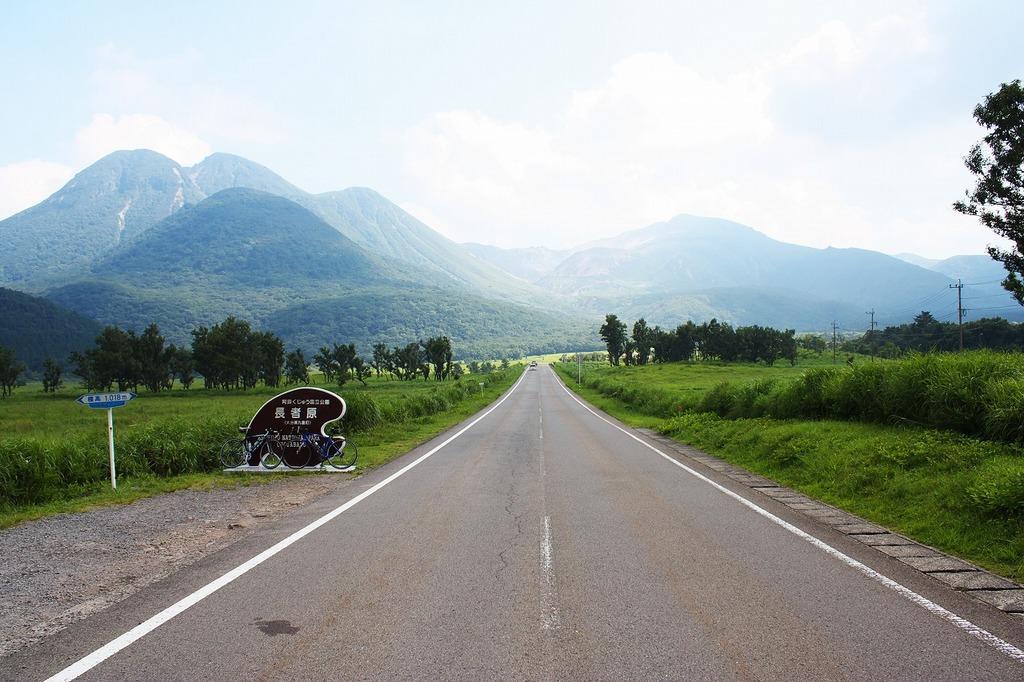How would you summarize this image in a sentence or two? The picture is taken along the countryside. In the foreground of the picture there are bicycles, soil, shrubs, plants, grass and road. In the center of the picture there are fields, trees, current poles and cables. In the background there are hills. Sky is sunny. 